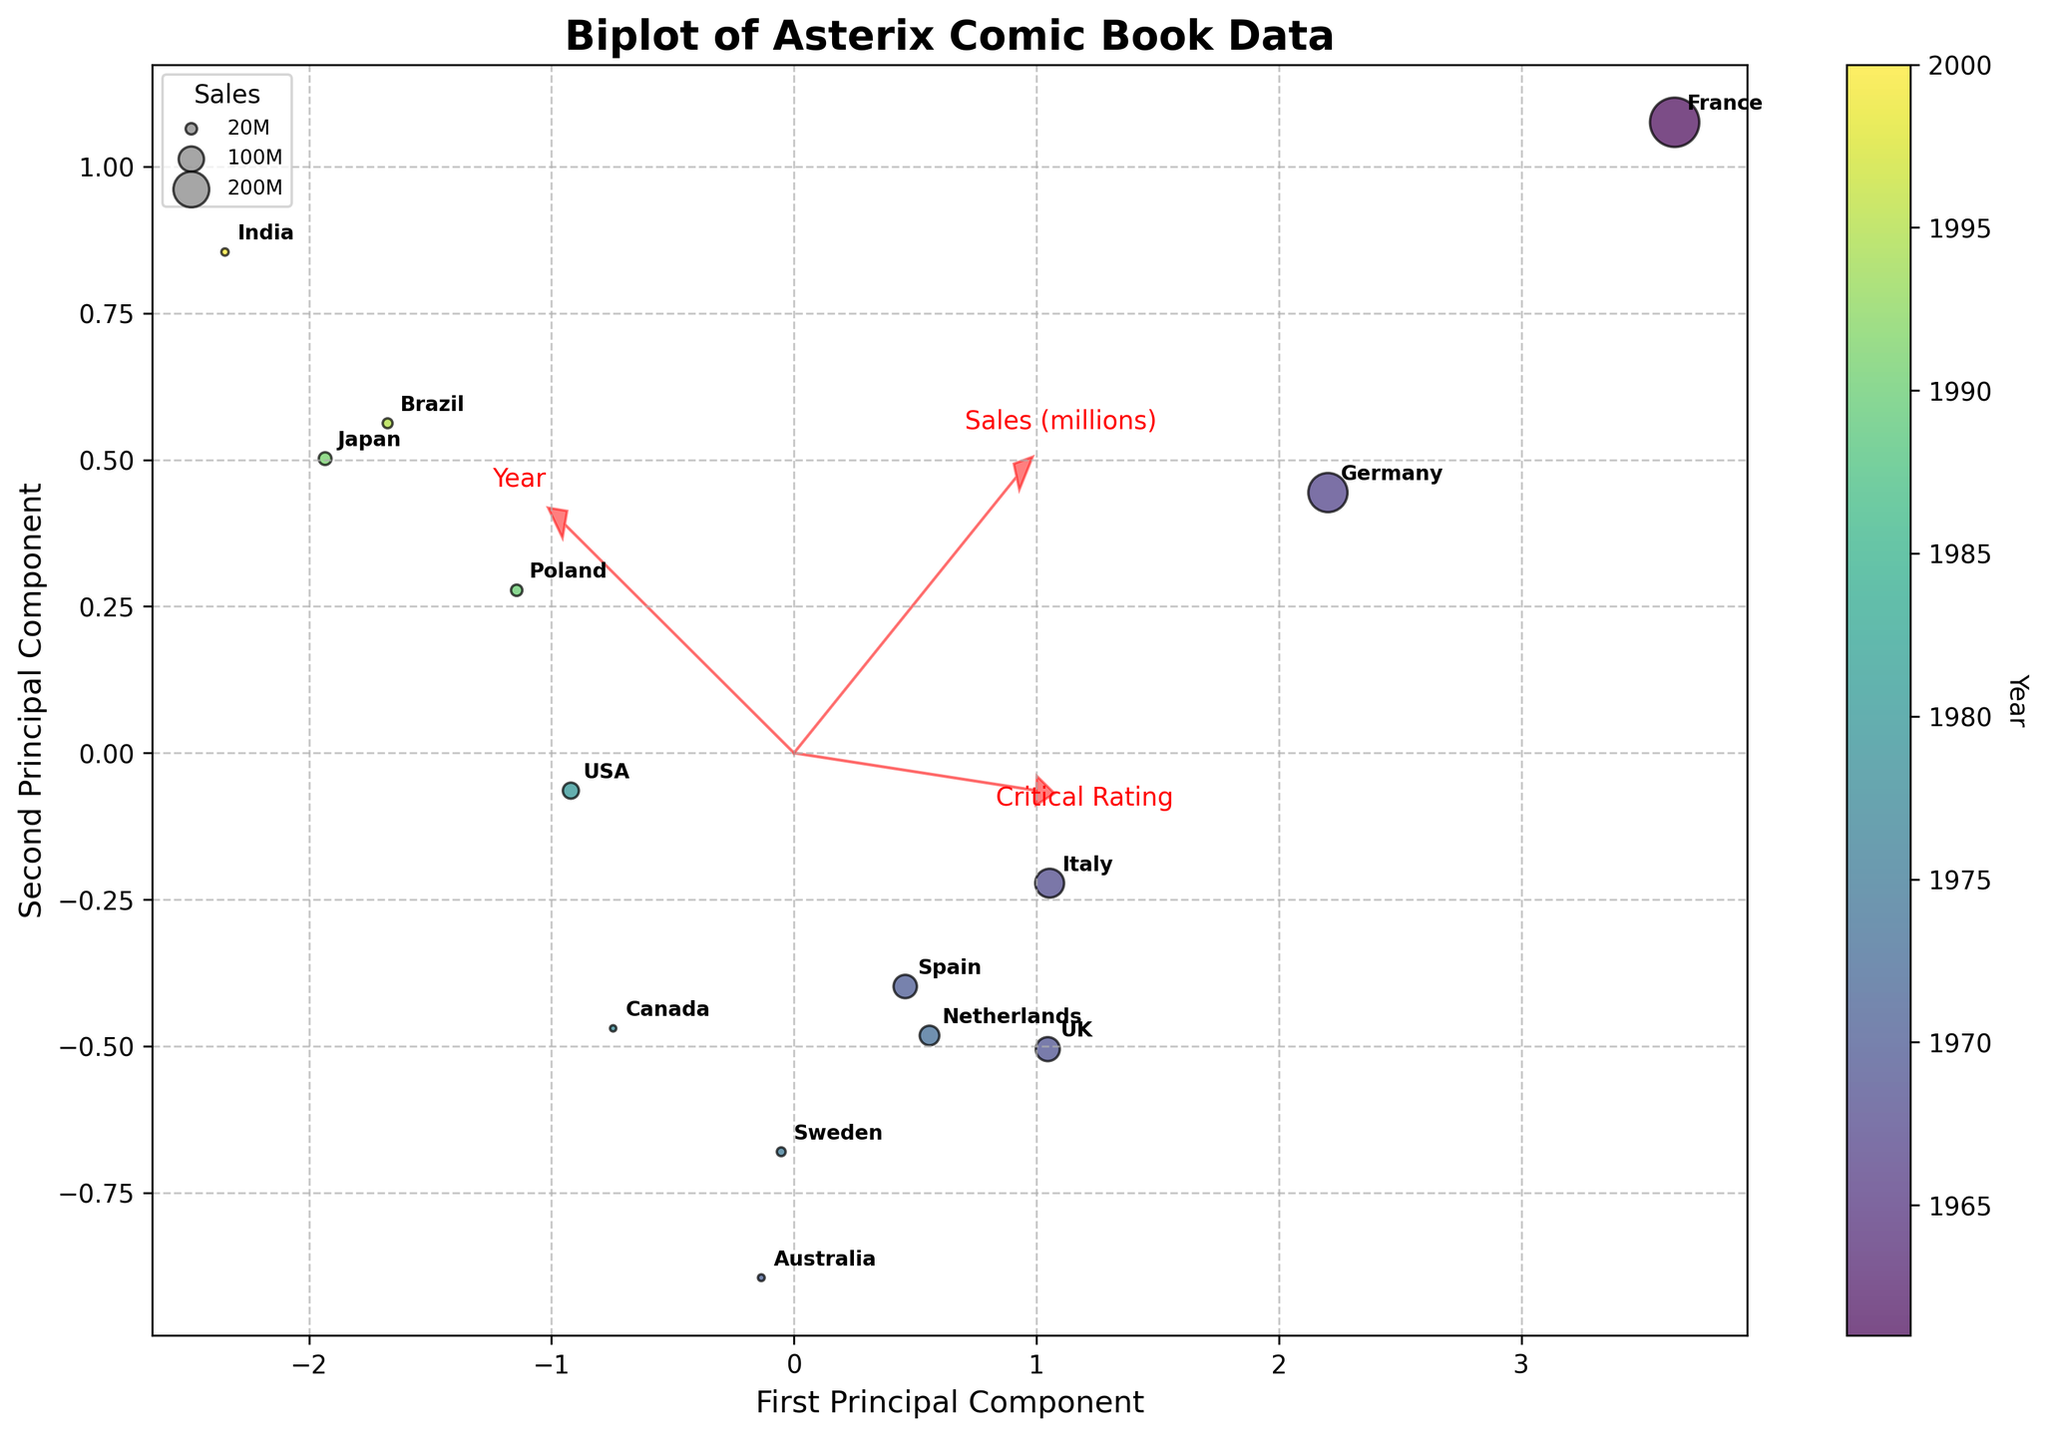what is the title of the figure? The title is clearly displayed at the top of the figure as "Biplot of Asterix Comic Book Data."
Answer: Biplot of Asterix Comic Book Data How are the data points colored in the plot? The data points are colored based on the 'Year' attribute, as indicated by the colorbar labeled 'Year' to the right of the figure.
Answer: By Year Which country has the highest sales, and how is it represented in the plot? The country with the highest sales is France with 380 million units sold. This is represented as the largest bubble on the scatter plot.
Answer: France Which countries are nearest to the origin in the PCA plot? The countries closest to the origin (0,0) in the PCA plot are USA and Japan since their bubbles are positioned nearest to the center of the plot.
Answer: USA, Japan How are the eigenvectors represented in the plot? The eigenvectors are represented by red arrows originating from the origin and pointing in directions that indicate the influence of each feature (Sales, Critical Rating, Year) on the first two principal components.
Answer: Red arrows Which country had the earliest critical reception year in the plot, and how is it indicated? France had the earliest critical reception year (1961), and this is indicated by the bubble with the most intense color (starting at the lowest end of the color spectrum in the colorbar).
Answer: France Which language group has the lowest sales, and where is it located on the plot? The language group with the lowest sales is English (India) with 8 million units. It is located on the left-most side of the plot.
Answer: English (India) How many eigenvectors are plotted, and why? Three eigenvectors are plotted, corresponding to the three features in the dataset: 'Sales (millions)', 'Critical Rating', and 'Year'. These vectors help in understanding the direction and scale of these features' influence.
Answer: Three Which data point has the highest critical rating, and what is its visual representation on the plot? The data point with the highest critical rating is France with a rating of 9.2. This is represented as a large bubble situated slightly towards the positive side of the first principal component.
Answer: France What does the first principal component axis represent? The first principal component axis represents a combination of the original features ('Sales (millions)', 'Critical Rating', and 'Year') in a way that maximizes the variance along this new axis.
Answer: Combination of original features to maximize variance 